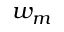Convert formula to latex. <formula><loc_0><loc_0><loc_500><loc_500>w _ { m }</formula> 